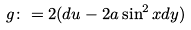<formula> <loc_0><loc_0><loc_500><loc_500>g \colon = 2 ( d u - 2 a \sin ^ { 2 } x d y )</formula> 